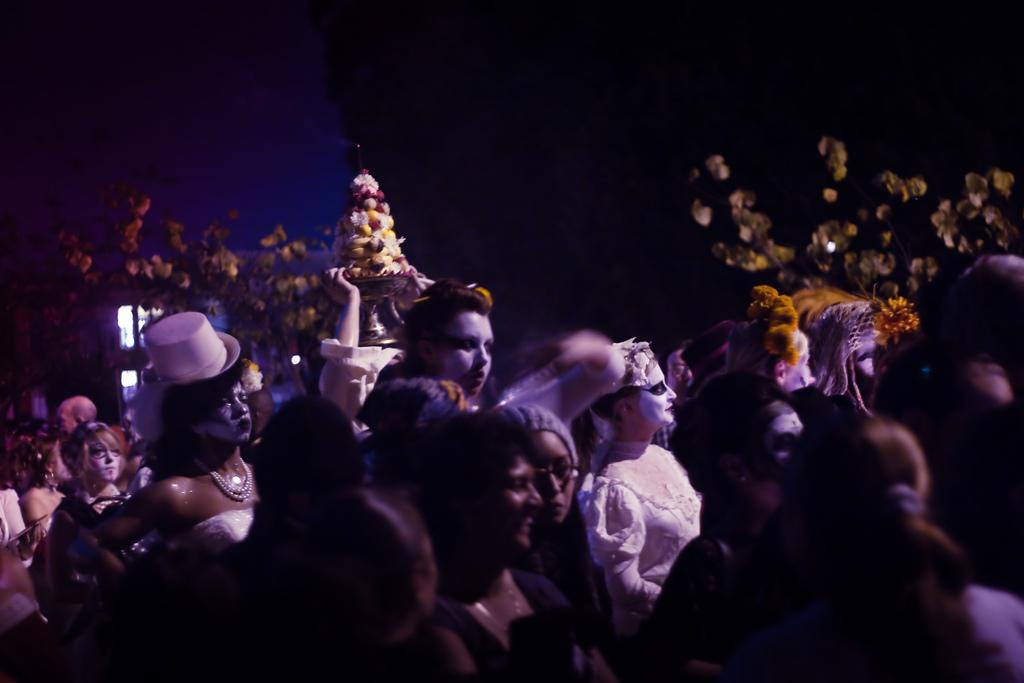How many people are present in the image? There are many people in the image. What are the people wearing? The people are wearing costumes. Can you describe the outfit of the woman in the image? The woman is wearing a white dress and a white hat. What can be seen in the background of the image? There are small plants in the background of the image. What type of fowl can be seen flying in the image? There is no fowl present in the image; it features people wearing costumes and small plants in the background. 